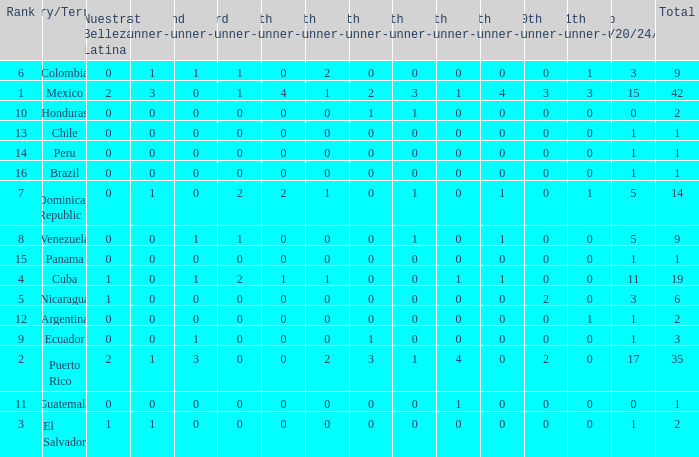Would you be able to parse every entry in this table? {'header': ['Rank', 'Country/Territory', 'Nuestra Belleza Latina', '1st runner-up', '2nd runner-up', '3rd runner-up', '4th runner-up', '5th runner-up', '6th runner-up', '7th runner-up', '8th runner-up', '9th runner-up', '10th runner-up', '11th runner-up', 'Top 18/20/24/30', 'Total'], 'rows': [['6', 'Colombia', '0', '1', '1', '1', '0', '2', '0', '0', '0', '0', '0', '1', '3', '9'], ['1', 'Mexico', '2', '3', '0', '1', '4', '1', '2', '3', '1', '4', '3', '3', '15', '42'], ['10', 'Honduras', '0', '0', '0', '0', '0', '0', '1', '1', '0', '0', '0', '0', '0', '2'], ['13', 'Chile', '0', '0', '0', '0', '0', '0', '0', '0', '0', '0', '0', '0', '1', '1'], ['14', 'Peru', '0', '0', '0', '0', '0', '0', '0', '0', '0', '0', '0', '0', '1', '1'], ['16', 'Brazil', '0', '0', '0', '0', '0', '0', '0', '0', '0', '0', '0', '0', '1', '1'], ['7', 'Dominican Republic', '0', '1', '0', '2', '2', '1', '0', '1', '0', '1', '0', '1', '5', '14'], ['8', 'Venezuela', '0', '0', '1', '1', '0', '0', '0', '1', '0', '1', '0', '0', '5', '9'], ['15', 'Panama', '0', '0', '0', '0', '0', '0', '0', '0', '0', '0', '0', '0', '1', '1'], ['4', 'Cuba', '1', '0', '1', '2', '1', '1', '0', '0', '1', '1', '0', '0', '11', '19'], ['5', 'Nicaragua', '1', '0', '0', '0', '0', '0', '0', '0', '0', '0', '2', '0', '3', '6'], ['12', 'Argentina', '0', '0', '0', '0', '0', '0', '0', '0', '0', '0', '0', '1', '1', '2'], ['9', 'Ecuador', '0', '0', '1', '0', '0', '0', '1', '0', '0', '0', '0', '0', '1', '3'], ['2', 'Puerto Rico', '2', '1', '3', '0', '0', '2', '3', '1', '4', '0', '2', '0', '17', '35'], ['11', 'Guatemala', '0', '0', '0', '0', '0', '0', '0', '0', '1', '0', '0', '0', '0', '1'], ['3', 'El Salvador', '1', '1', '0', '0', '0', '0', '0', '0', '0', '0', '0', '0', '1', '2']]} What is the 7th runner-up of the country with a 10th runner-up greater than 0, a 9th runner-up greater than 0, and an 8th runner-up greater than 1? None. 